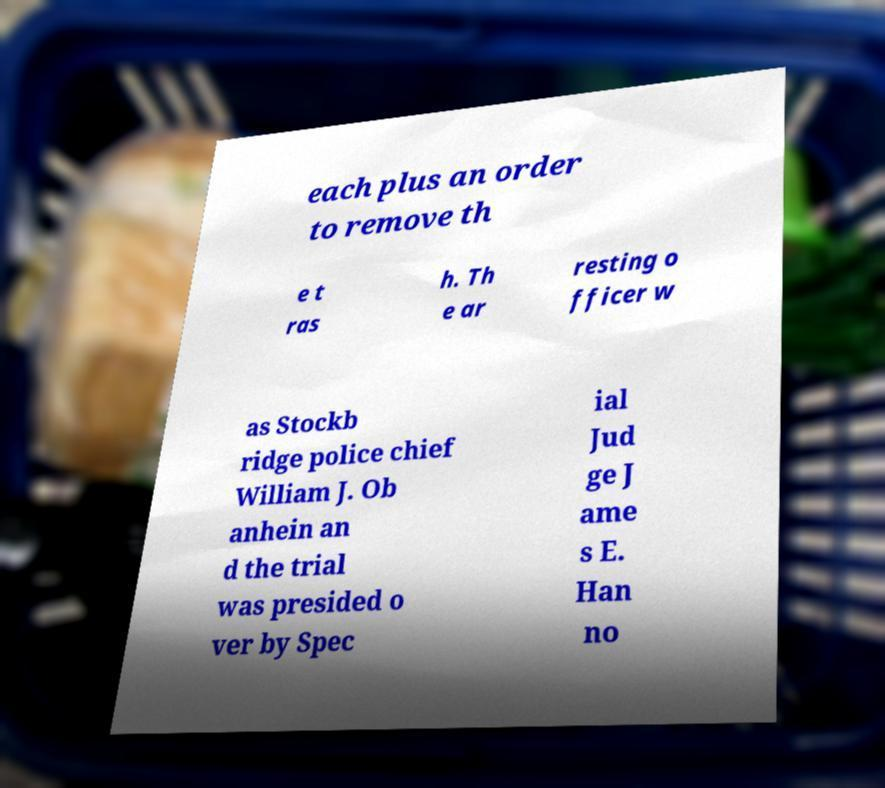For documentation purposes, I need the text within this image transcribed. Could you provide that? each plus an order to remove th e t ras h. Th e ar resting o fficer w as Stockb ridge police chief William J. Ob anhein an d the trial was presided o ver by Spec ial Jud ge J ame s E. Han no 